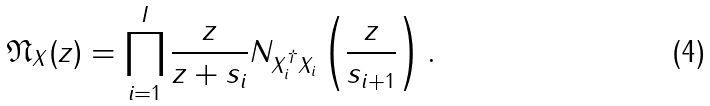<formula> <loc_0><loc_0><loc_500><loc_500>\mathfrak { N } _ { X } ( z ) = \prod _ { i = 1 } ^ { I } \frac { z } { z + s _ { i } } N _ { X _ { i } ^ { \dagger } X _ { i } } \left ( \frac { z } { s _ { i + 1 } } \right ) .</formula> 